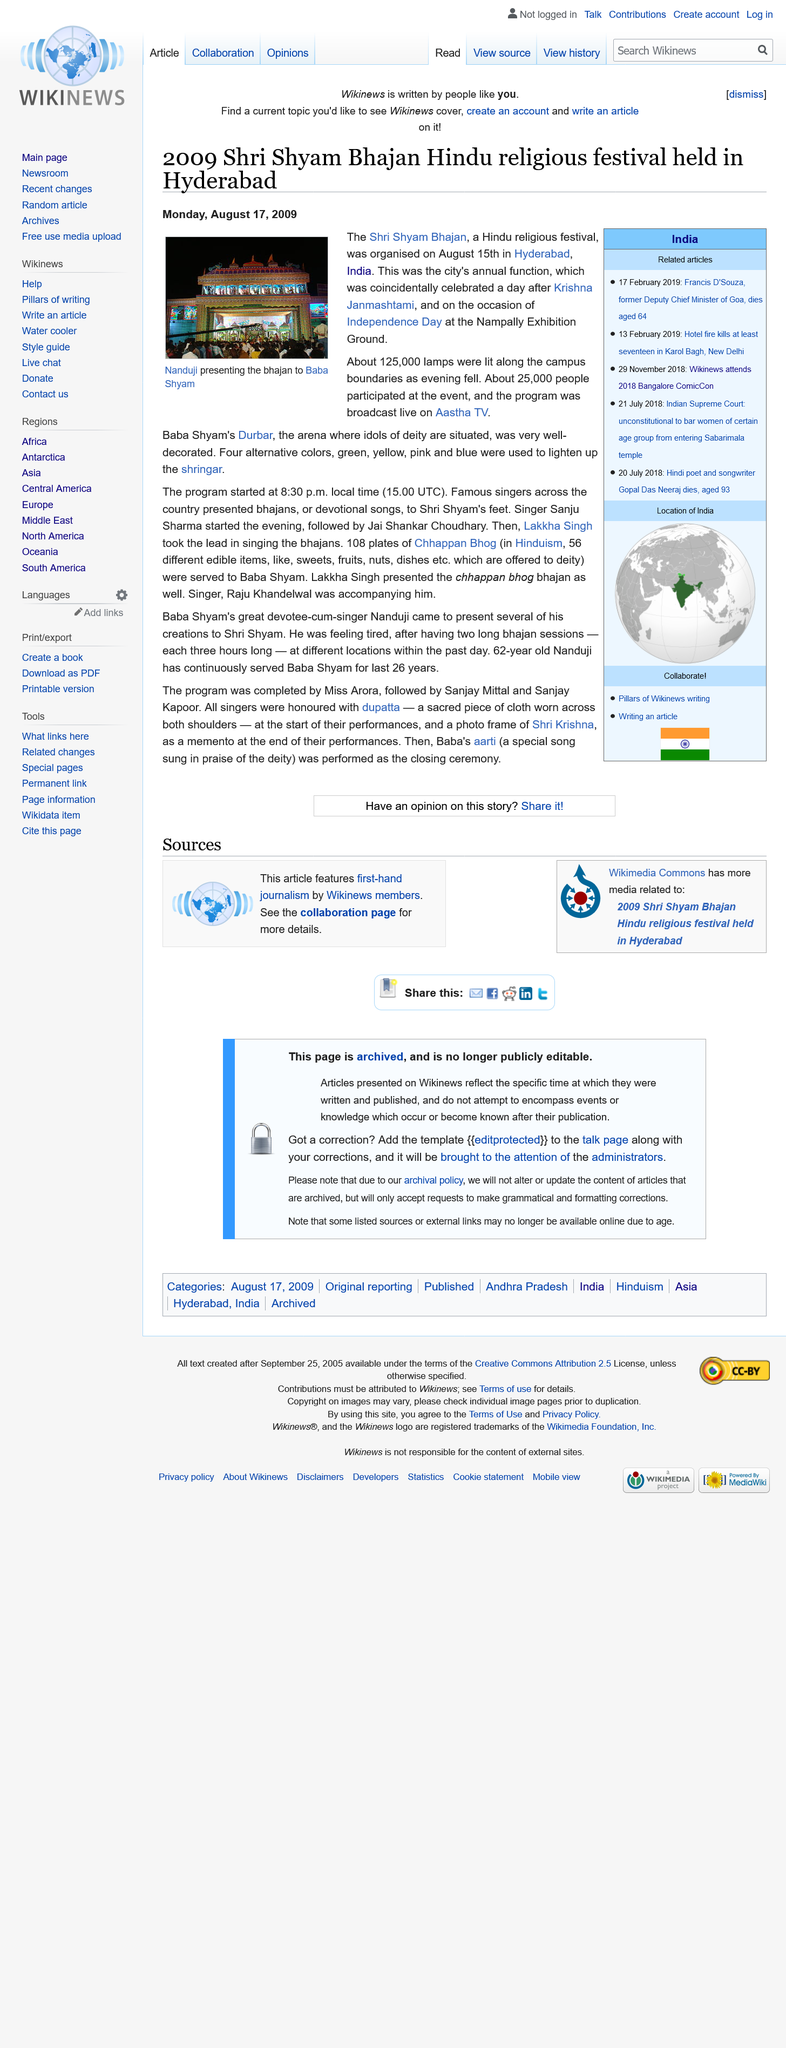Mention a couple of crucial points in this snapshot. On August 15th, 125,000 lamps were lit along the campus boundaries. A total of 25,000 people participated in the event. The Shri Shyam Bhajan Hindu festival was held in Hyderabad in 2009. 